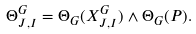Convert formula to latex. <formula><loc_0><loc_0><loc_500><loc_500>\Theta _ { J , I } ^ { G } = \Theta _ { G } ( X _ { J , I } ^ { G } ) \wedge \Theta _ { G } ( P ) .</formula> 